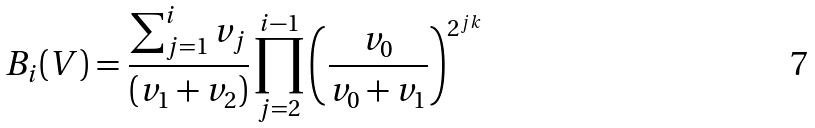<formula> <loc_0><loc_0><loc_500><loc_500>B _ { i } ( V ) = \frac { \sum _ { j = 1 } ^ { i } v _ { j } } { ( v _ { 1 } + v _ { 2 } ) } \prod _ { j = 2 } ^ { i - 1 } \left ( \frac { v _ { 0 } } { v _ { 0 } + v _ { 1 } } \right ) ^ { 2 ^ { j k } }</formula> 